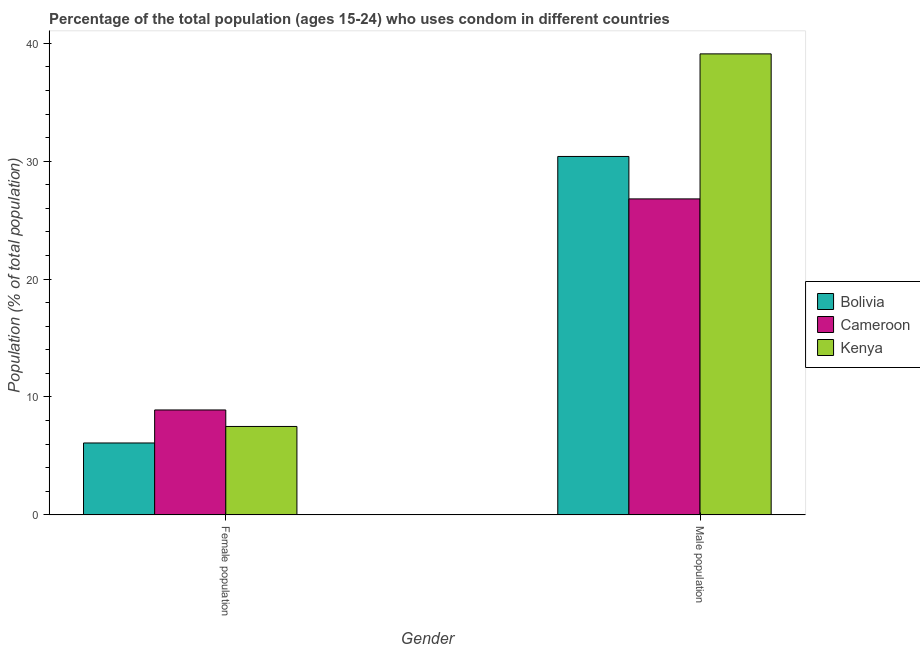How many different coloured bars are there?
Your answer should be compact. 3. How many groups of bars are there?
Offer a very short reply. 2. Are the number of bars on each tick of the X-axis equal?
Provide a short and direct response. Yes. How many bars are there on the 1st tick from the left?
Your answer should be very brief. 3. How many bars are there on the 1st tick from the right?
Make the answer very short. 3. What is the label of the 1st group of bars from the left?
Your answer should be compact. Female population. What is the female population in Cameroon?
Provide a short and direct response. 8.9. Across all countries, what is the maximum female population?
Offer a terse response. 8.9. Across all countries, what is the minimum male population?
Your answer should be compact. 26.8. In which country was the male population maximum?
Make the answer very short. Kenya. What is the total male population in the graph?
Make the answer very short. 96.3. What is the difference between the female population in Bolivia and that in Kenya?
Keep it short and to the point. -1.4. What is the difference between the female population and male population in Bolivia?
Offer a very short reply. -24.3. In how many countries, is the male population greater than 18 %?
Offer a very short reply. 3. What is the ratio of the female population in Bolivia to that in Cameroon?
Make the answer very short. 0.69. Is the male population in Cameroon less than that in Bolivia?
Your answer should be very brief. Yes. What does the 2nd bar from the left in Male population represents?
Keep it short and to the point. Cameroon. What does the 1st bar from the right in Female population represents?
Make the answer very short. Kenya. Are all the bars in the graph horizontal?
Ensure brevity in your answer.  No. What is the difference between two consecutive major ticks on the Y-axis?
Give a very brief answer. 10. Are the values on the major ticks of Y-axis written in scientific E-notation?
Ensure brevity in your answer.  No. Does the graph contain grids?
Give a very brief answer. No. What is the title of the graph?
Provide a short and direct response. Percentage of the total population (ages 15-24) who uses condom in different countries. Does "India" appear as one of the legend labels in the graph?
Provide a succinct answer. No. What is the label or title of the Y-axis?
Your response must be concise. Population (% of total population) . What is the Population (% of total population)  in Bolivia in Female population?
Give a very brief answer. 6.1. What is the Population (% of total population)  in Kenya in Female population?
Make the answer very short. 7.5. What is the Population (% of total population)  in Bolivia in Male population?
Your response must be concise. 30.4. What is the Population (% of total population)  of Cameroon in Male population?
Your response must be concise. 26.8. What is the Population (% of total population)  of Kenya in Male population?
Provide a short and direct response. 39.1. Across all Gender, what is the maximum Population (% of total population)  of Bolivia?
Provide a succinct answer. 30.4. Across all Gender, what is the maximum Population (% of total population)  in Cameroon?
Your answer should be compact. 26.8. Across all Gender, what is the maximum Population (% of total population)  in Kenya?
Your response must be concise. 39.1. Across all Gender, what is the minimum Population (% of total population)  in Cameroon?
Provide a succinct answer. 8.9. Across all Gender, what is the minimum Population (% of total population)  in Kenya?
Your answer should be very brief. 7.5. What is the total Population (% of total population)  in Bolivia in the graph?
Your response must be concise. 36.5. What is the total Population (% of total population)  of Cameroon in the graph?
Your answer should be very brief. 35.7. What is the total Population (% of total population)  in Kenya in the graph?
Your response must be concise. 46.6. What is the difference between the Population (% of total population)  of Bolivia in Female population and that in Male population?
Give a very brief answer. -24.3. What is the difference between the Population (% of total population)  of Cameroon in Female population and that in Male population?
Provide a succinct answer. -17.9. What is the difference between the Population (% of total population)  in Kenya in Female population and that in Male population?
Your answer should be very brief. -31.6. What is the difference between the Population (% of total population)  in Bolivia in Female population and the Population (% of total population)  in Cameroon in Male population?
Make the answer very short. -20.7. What is the difference between the Population (% of total population)  in Bolivia in Female population and the Population (% of total population)  in Kenya in Male population?
Provide a succinct answer. -33. What is the difference between the Population (% of total population)  of Cameroon in Female population and the Population (% of total population)  of Kenya in Male population?
Keep it short and to the point. -30.2. What is the average Population (% of total population)  of Bolivia per Gender?
Ensure brevity in your answer.  18.25. What is the average Population (% of total population)  in Cameroon per Gender?
Your answer should be compact. 17.85. What is the average Population (% of total population)  of Kenya per Gender?
Your answer should be very brief. 23.3. What is the difference between the Population (% of total population)  in Bolivia and Population (% of total population)  in Cameroon in Female population?
Offer a very short reply. -2.8. What is the difference between the Population (% of total population)  in Bolivia and Population (% of total population)  in Kenya in Female population?
Make the answer very short. -1.4. What is the difference between the Population (% of total population)  of Cameroon and Population (% of total population)  of Kenya in Female population?
Offer a terse response. 1.4. What is the ratio of the Population (% of total population)  of Bolivia in Female population to that in Male population?
Your answer should be compact. 0.2. What is the ratio of the Population (% of total population)  of Cameroon in Female population to that in Male population?
Your answer should be compact. 0.33. What is the ratio of the Population (% of total population)  of Kenya in Female population to that in Male population?
Your answer should be compact. 0.19. What is the difference between the highest and the second highest Population (% of total population)  in Bolivia?
Make the answer very short. 24.3. What is the difference between the highest and the second highest Population (% of total population)  of Kenya?
Offer a very short reply. 31.6. What is the difference between the highest and the lowest Population (% of total population)  of Bolivia?
Offer a very short reply. 24.3. What is the difference between the highest and the lowest Population (% of total population)  in Cameroon?
Your answer should be very brief. 17.9. What is the difference between the highest and the lowest Population (% of total population)  of Kenya?
Provide a succinct answer. 31.6. 